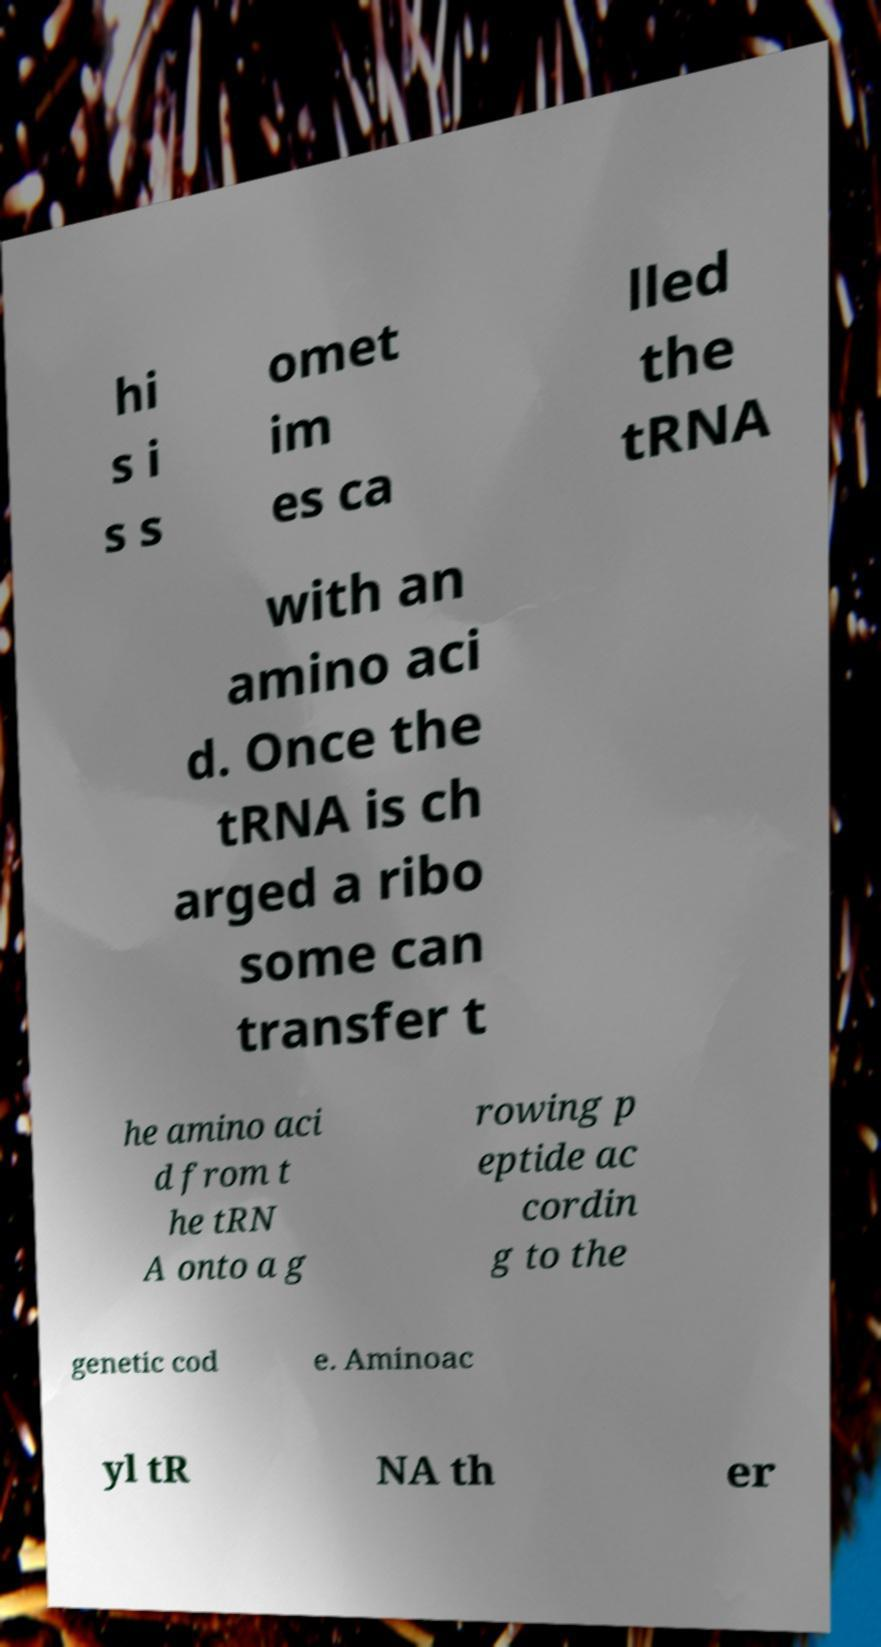Please identify and transcribe the text found in this image. hi s i s s omet im es ca lled the tRNA with an amino aci d. Once the tRNA is ch arged a ribo some can transfer t he amino aci d from t he tRN A onto a g rowing p eptide ac cordin g to the genetic cod e. Aminoac yl tR NA th er 